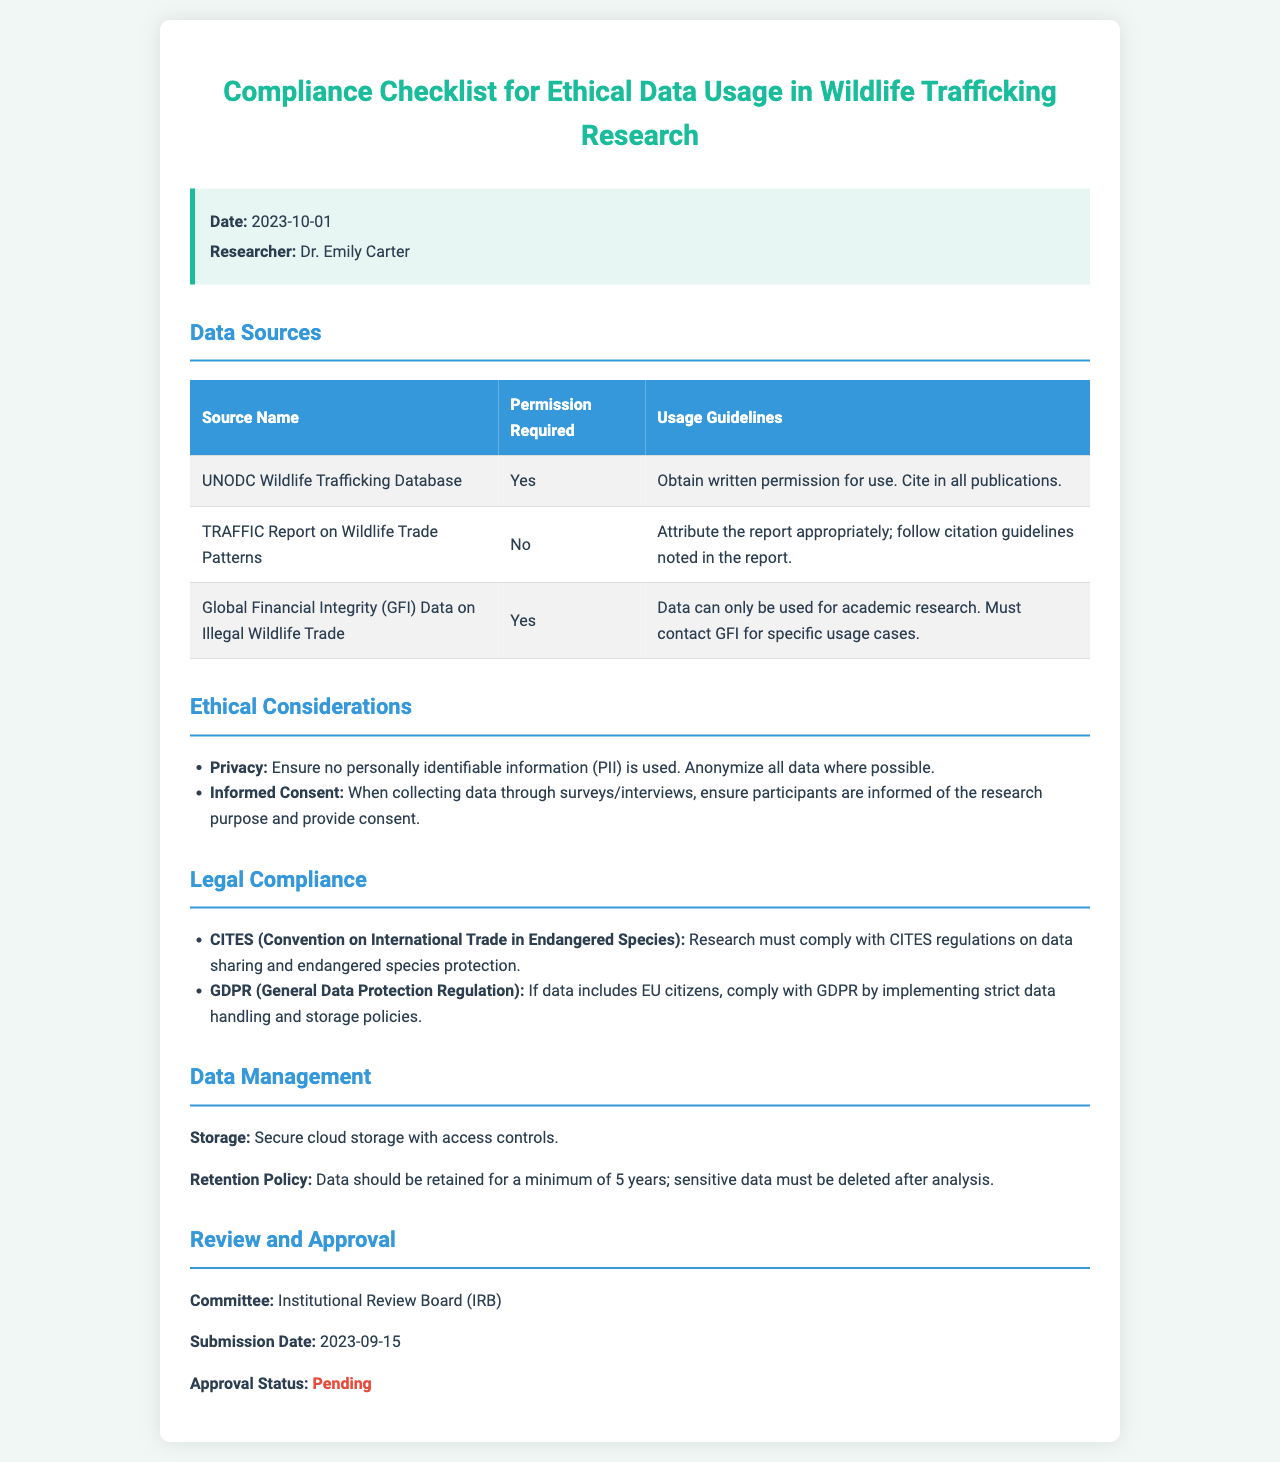What is the date of the compliance checklist? The date is listed in the info box at the top of the document.
Answer: 2023-10-01 Who is the researcher mentioned in the compliance checklist? The researcher's name is noted in the info box, which provides details about the researcher.
Answer: Dr. Emily Carter Is permission required for the UNODC Wildlife Trafficking Database? The table lists whether permission is required for each data source.
Answer: Yes What is the usage guideline for the TRAFFIC Report on Wildlife Trade Patterns? The guidelines are specified in the 'Usage Guidelines' column of the table for that data source.
Answer: Attribute the report appropriately; follow citation guidelines noted in the report Which committee reviews the research for compliance? The review and approval section specifies the responsible committee for oversight.
Answer: Institutional Review Board (IRB) What is the approval status as of the submission date? The approval status is mentioned in the review section, indicating the current state of approval.
Answer: Pending What is the minimum data retention period mentioned in the document? The document specifies the data retention policy detailing how long data should be kept.
Answer: 5 years Which legal compliance relation is mentioned regarding EU citizens? The legal compliance section outlines specific regulations that are applicable in different contexts.
Answer: GDPR What type of data must be anonymized according to ethical considerations? The ethical considerations section specifies requirements regarding data privacy and identification.
Answer: Personally identifiable information (PII) 